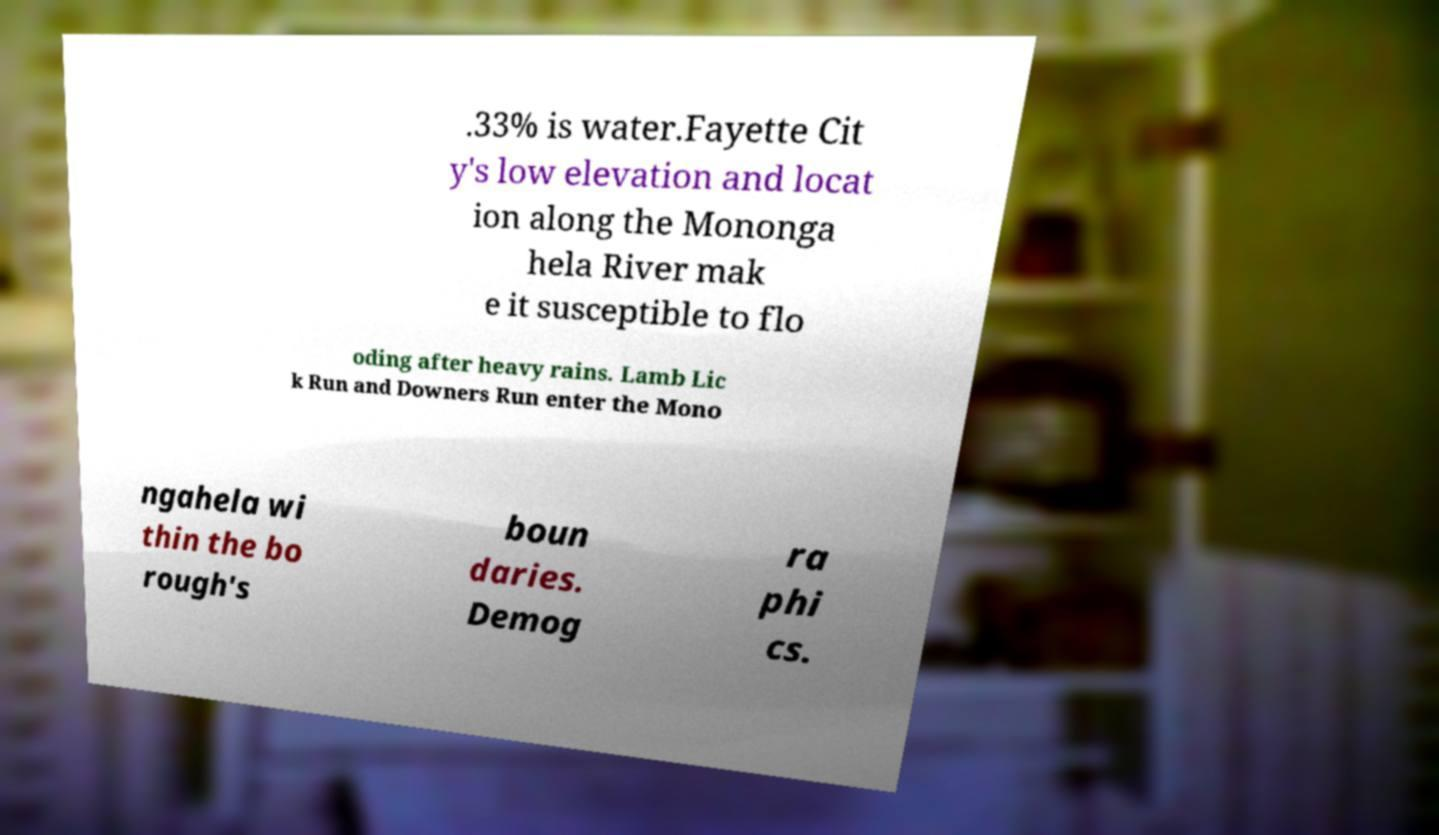Can you read and provide the text displayed in the image?This photo seems to have some interesting text. Can you extract and type it out for me? .33% is water.Fayette Cit y's low elevation and locat ion along the Mononga hela River mak e it susceptible to flo oding after heavy rains. Lamb Lic k Run and Downers Run enter the Mono ngahela wi thin the bo rough's boun daries. Demog ra phi cs. 